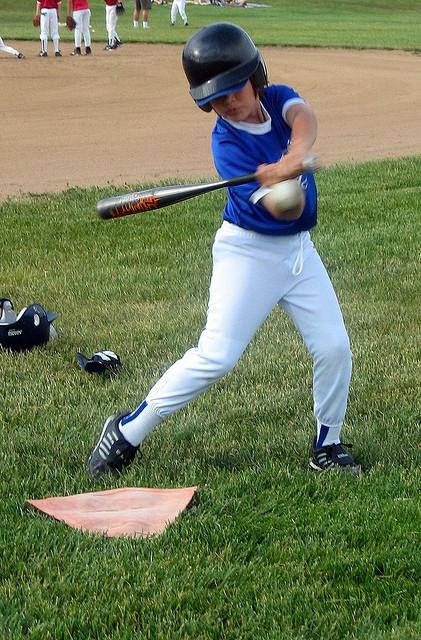What is the bats brand?
Keep it brief. Rawlings. Is the boy wearing protective headgear?
Keep it brief. Yes. What is the boy standing on?
Concise answer only. Grass. 